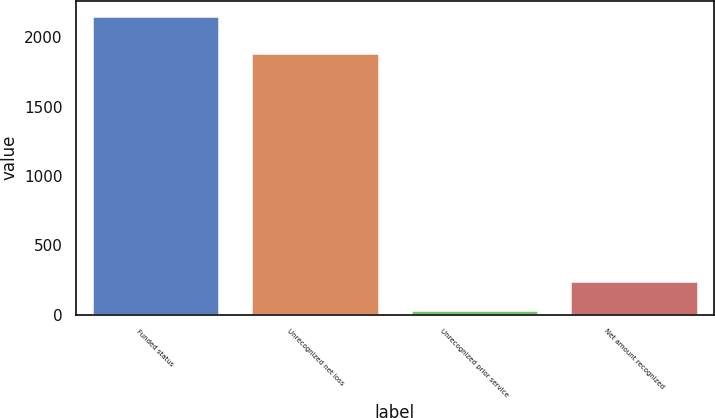Convert chart to OTSL. <chart><loc_0><loc_0><loc_500><loc_500><bar_chart><fcel>Funded status<fcel>Unrecognized net loss<fcel>Unrecognized prior service<fcel>Net amount recognized<nl><fcel>2155<fcel>1884<fcel>33<fcel>245.2<nl></chart> 